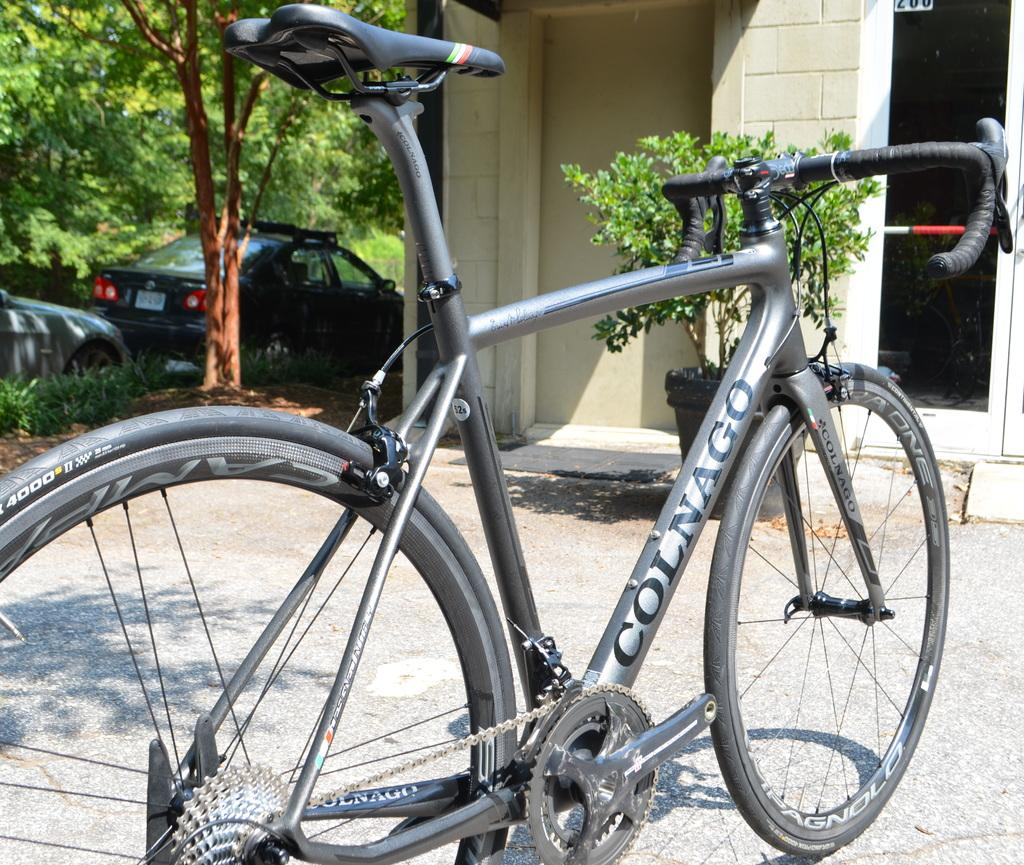What is the main object in the image? There is a bicycle in the image. How is the bicycle positioned in the image? The bicycle is placed on the ground. What other structures can be seen in the image? There is a building and cars parked in the image. Are there any plants or vegetation in the image? Yes, there is a plant in a pot, plants visible, and a group of trees in the image. What type of cake is being served at the war depicted in the image? There is no war or cake present in the image; it features a bicycle, a building, plants, and parked cars. 